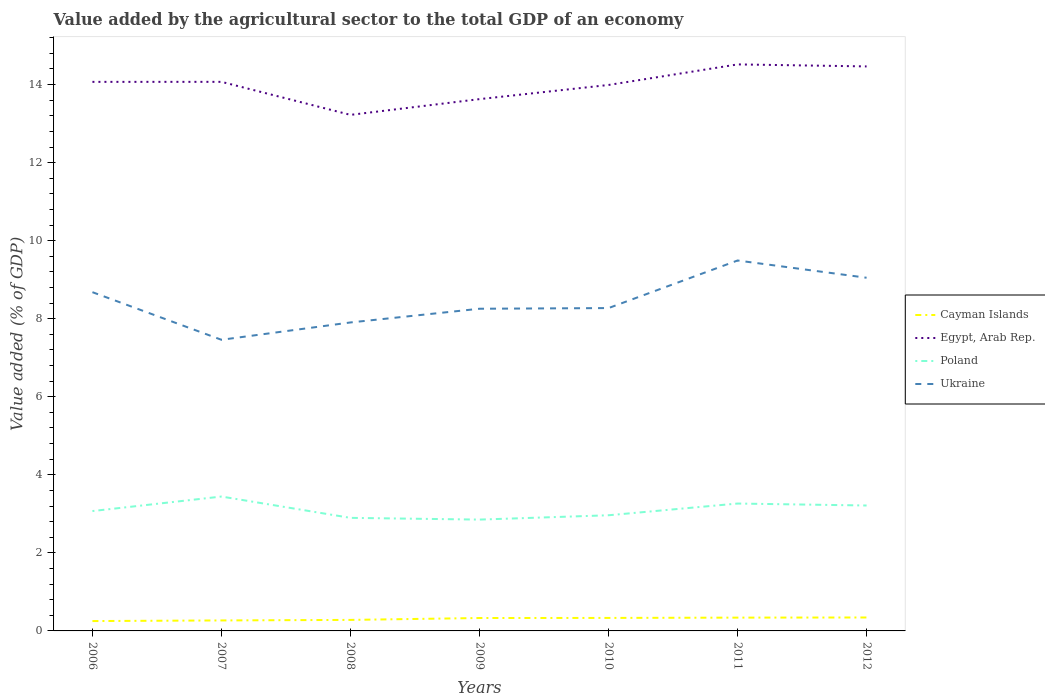How many different coloured lines are there?
Offer a terse response. 4. Across all years, what is the maximum value added by the agricultural sector to the total GDP in Poland?
Offer a very short reply. 2.85. In which year was the value added by the agricultural sector to the total GDP in Poland maximum?
Give a very brief answer. 2009. What is the total value added by the agricultural sector to the total GDP in Poland in the graph?
Make the answer very short. 0.17. What is the difference between the highest and the second highest value added by the agricultural sector to the total GDP in Cayman Islands?
Your response must be concise. 0.09. What is the difference between the highest and the lowest value added by the agricultural sector to the total GDP in Poland?
Your response must be concise. 3. Is the value added by the agricultural sector to the total GDP in Ukraine strictly greater than the value added by the agricultural sector to the total GDP in Egypt, Arab Rep. over the years?
Provide a succinct answer. Yes. How many lines are there?
Your response must be concise. 4. What is the difference between two consecutive major ticks on the Y-axis?
Your response must be concise. 2. Are the values on the major ticks of Y-axis written in scientific E-notation?
Give a very brief answer. No. Does the graph contain any zero values?
Offer a terse response. No. Where does the legend appear in the graph?
Ensure brevity in your answer.  Center right. How are the legend labels stacked?
Make the answer very short. Vertical. What is the title of the graph?
Your response must be concise. Value added by the agricultural sector to the total GDP of an economy. What is the label or title of the Y-axis?
Provide a short and direct response. Value added (% of GDP). What is the Value added (% of GDP) in Cayman Islands in 2006?
Give a very brief answer. 0.25. What is the Value added (% of GDP) of Egypt, Arab Rep. in 2006?
Provide a succinct answer. 14.07. What is the Value added (% of GDP) of Poland in 2006?
Provide a succinct answer. 3.07. What is the Value added (% of GDP) in Ukraine in 2006?
Give a very brief answer. 8.68. What is the Value added (% of GDP) in Cayman Islands in 2007?
Provide a succinct answer. 0.27. What is the Value added (% of GDP) in Egypt, Arab Rep. in 2007?
Provide a succinct answer. 14.07. What is the Value added (% of GDP) in Poland in 2007?
Make the answer very short. 3.44. What is the Value added (% of GDP) in Ukraine in 2007?
Make the answer very short. 7.46. What is the Value added (% of GDP) in Cayman Islands in 2008?
Give a very brief answer. 0.28. What is the Value added (% of GDP) in Egypt, Arab Rep. in 2008?
Keep it short and to the point. 13.22. What is the Value added (% of GDP) of Poland in 2008?
Offer a very short reply. 2.9. What is the Value added (% of GDP) of Ukraine in 2008?
Your response must be concise. 7.9. What is the Value added (% of GDP) in Cayman Islands in 2009?
Give a very brief answer. 0.33. What is the Value added (% of GDP) of Egypt, Arab Rep. in 2009?
Give a very brief answer. 13.63. What is the Value added (% of GDP) of Poland in 2009?
Offer a very short reply. 2.85. What is the Value added (% of GDP) of Ukraine in 2009?
Offer a terse response. 8.26. What is the Value added (% of GDP) of Cayman Islands in 2010?
Offer a very short reply. 0.33. What is the Value added (% of GDP) in Egypt, Arab Rep. in 2010?
Provide a succinct answer. 13.99. What is the Value added (% of GDP) in Poland in 2010?
Provide a succinct answer. 2.96. What is the Value added (% of GDP) in Ukraine in 2010?
Make the answer very short. 8.27. What is the Value added (% of GDP) of Cayman Islands in 2011?
Offer a terse response. 0.34. What is the Value added (% of GDP) in Egypt, Arab Rep. in 2011?
Offer a terse response. 14.52. What is the Value added (% of GDP) in Poland in 2011?
Offer a very short reply. 3.26. What is the Value added (% of GDP) of Ukraine in 2011?
Provide a short and direct response. 9.49. What is the Value added (% of GDP) in Cayman Islands in 2012?
Keep it short and to the point. 0.34. What is the Value added (% of GDP) in Egypt, Arab Rep. in 2012?
Offer a very short reply. 14.47. What is the Value added (% of GDP) of Poland in 2012?
Your answer should be compact. 3.21. What is the Value added (% of GDP) of Ukraine in 2012?
Offer a very short reply. 9.05. Across all years, what is the maximum Value added (% of GDP) in Cayman Islands?
Provide a short and direct response. 0.34. Across all years, what is the maximum Value added (% of GDP) in Egypt, Arab Rep.?
Your answer should be compact. 14.52. Across all years, what is the maximum Value added (% of GDP) of Poland?
Ensure brevity in your answer.  3.44. Across all years, what is the maximum Value added (% of GDP) in Ukraine?
Provide a succinct answer. 9.49. Across all years, what is the minimum Value added (% of GDP) of Cayman Islands?
Offer a very short reply. 0.25. Across all years, what is the minimum Value added (% of GDP) in Egypt, Arab Rep.?
Provide a succinct answer. 13.22. Across all years, what is the minimum Value added (% of GDP) in Poland?
Your answer should be very brief. 2.85. Across all years, what is the minimum Value added (% of GDP) of Ukraine?
Offer a terse response. 7.46. What is the total Value added (% of GDP) of Cayman Islands in the graph?
Your response must be concise. 2.15. What is the total Value added (% of GDP) in Egypt, Arab Rep. in the graph?
Offer a very short reply. 97.96. What is the total Value added (% of GDP) in Poland in the graph?
Your answer should be very brief. 21.71. What is the total Value added (% of GDP) in Ukraine in the graph?
Your answer should be very brief. 59.12. What is the difference between the Value added (% of GDP) of Cayman Islands in 2006 and that in 2007?
Provide a short and direct response. -0.02. What is the difference between the Value added (% of GDP) in Egypt, Arab Rep. in 2006 and that in 2007?
Provide a succinct answer. -0. What is the difference between the Value added (% of GDP) of Poland in 2006 and that in 2007?
Make the answer very short. -0.37. What is the difference between the Value added (% of GDP) of Ukraine in 2006 and that in 2007?
Offer a terse response. 1.22. What is the difference between the Value added (% of GDP) of Cayman Islands in 2006 and that in 2008?
Keep it short and to the point. -0.03. What is the difference between the Value added (% of GDP) of Egypt, Arab Rep. in 2006 and that in 2008?
Make the answer very short. 0.85. What is the difference between the Value added (% of GDP) of Poland in 2006 and that in 2008?
Ensure brevity in your answer.  0.17. What is the difference between the Value added (% of GDP) of Ukraine in 2006 and that in 2008?
Ensure brevity in your answer.  0.78. What is the difference between the Value added (% of GDP) in Cayman Islands in 2006 and that in 2009?
Offer a very short reply. -0.08. What is the difference between the Value added (% of GDP) in Egypt, Arab Rep. in 2006 and that in 2009?
Make the answer very short. 0.44. What is the difference between the Value added (% of GDP) of Poland in 2006 and that in 2009?
Keep it short and to the point. 0.22. What is the difference between the Value added (% of GDP) in Ukraine in 2006 and that in 2009?
Provide a short and direct response. 0.42. What is the difference between the Value added (% of GDP) of Cayman Islands in 2006 and that in 2010?
Offer a terse response. -0.08. What is the difference between the Value added (% of GDP) of Egypt, Arab Rep. in 2006 and that in 2010?
Your answer should be compact. 0.08. What is the difference between the Value added (% of GDP) of Poland in 2006 and that in 2010?
Offer a terse response. 0.11. What is the difference between the Value added (% of GDP) of Ukraine in 2006 and that in 2010?
Give a very brief answer. 0.41. What is the difference between the Value added (% of GDP) in Cayman Islands in 2006 and that in 2011?
Ensure brevity in your answer.  -0.09. What is the difference between the Value added (% of GDP) in Egypt, Arab Rep. in 2006 and that in 2011?
Your response must be concise. -0.45. What is the difference between the Value added (% of GDP) in Poland in 2006 and that in 2011?
Provide a short and direct response. -0.19. What is the difference between the Value added (% of GDP) in Ukraine in 2006 and that in 2011?
Keep it short and to the point. -0.81. What is the difference between the Value added (% of GDP) of Cayman Islands in 2006 and that in 2012?
Make the answer very short. -0.09. What is the difference between the Value added (% of GDP) of Egypt, Arab Rep. in 2006 and that in 2012?
Your response must be concise. -0.4. What is the difference between the Value added (% of GDP) of Poland in 2006 and that in 2012?
Your response must be concise. -0.14. What is the difference between the Value added (% of GDP) in Ukraine in 2006 and that in 2012?
Make the answer very short. -0.37. What is the difference between the Value added (% of GDP) in Cayman Islands in 2007 and that in 2008?
Your answer should be compact. -0.01. What is the difference between the Value added (% of GDP) of Egypt, Arab Rep. in 2007 and that in 2008?
Your answer should be very brief. 0.85. What is the difference between the Value added (% of GDP) in Poland in 2007 and that in 2008?
Provide a succinct answer. 0.55. What is the difference between the Value added (% of GDP) in Ukraine in 2007 and that in 2008?
Your response must be concise. -0.44. What is the difference between the Value added (% of GDP) of Cayman Islands in 2007 and that in 2009?
Ensure brevity in your answer.  -0.06. What is the difference between the Value added (% of GDP) of Egypt, Arab Rep. in 2007 and that in 2009?
Your response must be concise. 0.44. What is the difference between the Value added (% of GDP) of Poland in 2007 and that in 2009?
Offer a terse response. 0.59. What is the difference between the Value added (% of GDP) of Ukraine in 2007 and that in 2009?
Your response must be concise. -0.8. What is the difference between the Value added (% of GDP) of Cayman Islands in 2007 and that in 2010?
Ensure brevity in your answer.  -0.06. What is the difference between the Value added (% of GDP) in Egypt, Arab Rep. in 2007 and that in 2010?
Provide a succinct answer. 0.08. What is the difference between the Value added (% of GDP) of Poland in 2007 and that in 2010?
Your answer should be very brief. 0.48. What is the difference between the Value added (% of GDP) in Ukraine in 2007 and that in 2010?
Your response must be concise. -0.81. What is the difference between the Value added (% of GDP) in Cayman Islands in 2007 and that in 2011?
Offer a terse response. -0.07. What is the difference between the Value added (% of GDP) of Egypt, Arab Rep. in 2007 and that in 2011?
Provide a succinct answer. -0.45. What is the difference between the Value added (% of GDP) of Poland in 2007 and that in 2011?
Your answer should be very brief. 0.18. What is the difference between the Value added (% of GDP) in Ukraine in 2007 and that in 2011?
Ensure brevity in your answer.  -2.03. What is the difference between the Value added (% of GDP) of Cayman Islands in 2007 and that in 2012?
Your answer should be very brief. -0.08. What is the difference between the Value added (% of GDP) in Egypt, Arab Rep. in 2007 and that in 2012?
Give a very brief answer. -0.4. What is the difference between the Value added (% of GDP) in Poland in 2007 and that in 2012?
Your response must be concise. 0.23. What is the difference between the Value added (% of GDP) in Ukraine in 2007 and that in 2012?
Offer a terse response. -1.59. What is the difference between the Value added (% of GDP) in Cayman Islands in 2008 and that in 2009?
Offer a very short reply. -0.05. What is the difference between the Value added (% of GDP) in Egypt, Arab Rep. in 2008 and that in 2009?
Offer a terse response. -0.4. What is the difference between the Value added (% of GDP) of Poland in 2008 and that in 2009?
Give a very brief answer. 0.04. What is the difference between the Value added (% of GDP) of Ukraine in 2008 and that in 2009?
Provide a succinct answer. -0.35. What is the difference between the Value added (% of GDP) of Cayman Islands in 2008 and that in 2010?
Your answer should be compact. -0.05. What is the difference between the Value added (% of GDP) in Egypt, Arab Rep. in 2008 and that in 2010?
Ensure brevity in your answer.  -0.77. What is the difference between the Value added (% of GDP) of Poland in 2008 and that in 2010?
Your answer should be very brief. -0.07. What is the difference between the Value added (% of GDP) of Ukraine in 2008 and that in 2010?
Your answer should be compact. -0.37. What is the difference between the Value added (% of GDP) of Cayman Islands in 2008 and that in 2011?
Your response must be concise. -0.06. What is the difference between the Value added (% of GDP) of Egypt, Arab Rep. in 2008 and that in 2011?
Your answer should be compact. -1.29. What is the difference between the Value added (% of GDP) of Poland in 2008 and that in 2011?
Offer a very short reply. -0.37. What is the difference between the Value added (% of GDP) in Ukraine in 2008 and that in 2011?
Provide a succinct answer. -1.59. What is the difference between the Value added (% of GDP) of Cayman Islands in 2008 and that in 2012?
Your response must be concise. -0.06. What is the difference between the Value added (% of GDP) of Egypt, Arab Rep. in 2008 and that in 2012?
Provide a succinct answer. -1.24. What is the difference between the Value added (% of GDP) in Poland in 2008 and that in 2012?
Your answer should be very brief. -0.32. What is the difference between the Value added (% of GDP) of Ukraine in 2008 and that in 2012?
Your answer should be compact. -1.15. What is the difference between the Value added (% of GDP) in Cayman Islands in 2009 and that in 2010?
Make the answer very short. -0. What is the difference between the Value added (% of GDP) in Egypt, Arab Rep. in 2009 and that in 2010?
Your answer should be very brief. -0.36. What is the difference between the Value added (% of GDP) of Poland in 2009 and that in 2010?
Offer a very short reply. -0.11. What is the difference between the Value added (% of GDP) of Ukraine in 2009 and that in 2010?
Offer a terse response. -0.02. What is the difference between the Value added (% of GDP) in Cayman Islands in 2009 and that in 2011?
Offer a very short reply. -0.01. What is the difference between the Value added (% of GDP) in Egypt, Arab Rep. in 2009 and that in 2011?
Keep it short and to the point. -0.89. What is the difference between the Value added (% of GDP) of Poland in 2009 and that in 2011?
Offer a terse response. -0.41. What is the difference between the Value added (% of GDP) in Ukraine in 2009 and that in 2011?
Keep it short and to the point. -1.24. What is the difference between the Value added (% of GDP) of Cayman Islands in 2009 and that in 2012?
Your answer should be compact. -0.01. What is the difference between the Value added (% of GDP) of Egypt, Arab Rep. in 2009 and that in 2012?
Your answer should be very brief. -0.84. What is the difference between the Value added (% of GDP) in Poland in 2009 and that in 2012?
Offer a very short reply. -0.36. What is the difference between the Value added (% of GDP) of Ukraine in 2009 and that in 2012?
Your answer should be compact. -0.79. What is the difference between the Value added (% of GDP) in Cayman Islands in 2010 and that in 2011?
Your answer should be very brief. -0.01. What is the difference between the Value added (% of GDP) in Egypt, Arab Rep. in 2010 and that in 2011?
Give a very brief answer. -0.53. What is the difference between the Value added (% of GDP) of Poland in 2010 and that in 2011?
Your response must be concise. -0.3. What is the difference between the Value added (% of GDP) of Ukraine in 2010 and that in 2011?
Keep it short and to the point. -1.22. What is the difference between the Value added (% of GDP) of Cayman Islands in 2010 and that in 2012?
Make the answer very short. -0.01. What is the difference between the Value added (% of GDP) of Egypt, Arab Rep. in 2010 and that in 2012?
Offer a very short reply. -0.48. What is the difference between the Value added (% of GDP) of Ukraine in 2010 and that in 2012?
Provide a succinct answer. -0.78. What is the difference between the Value added (% of GDP) in Cayman Islands in 2011 and that in 2012?
Your response must be concise. -0. What is the difference between the Value added (% of GDP) of Egypt, Arab Rep. in 2011 and that in 2012?
Offer a very short reply. 0.05. What is the difference between the Value added (% of GDP) in Poland in 2011 and that in 2012?
Offer a very short reply. 0.05. What is the difference between the Value added (% of GDP) in Ukraine in 2011 and that in 2012?
Make the answer very short. 0.44. What is the difference between the Value added (% of GDP) in Cayman Islands in 2006 and the Value added (% of GDP) in Egypt, Arab Rep. in 2007?
Offer a terse response. -13.82. What is the difference between the Value added (% of GDP) in Cayman Islands in 2006 and the Value added (% of GDP) in Poland in 2007?
Your answer should be compact. -3.19. What is the difference between the Value added (% of GDP) in Cayman Islands in 2006 and the Value added (% of GDP) in Ukraine in 2007?
Give a very brief answer. -7.21. What is the difference between the Value added (% of GDP) of Egypt, Arab Rep. in 2006 and the Value added (% of GDP) of Poland in 2007?
Ensure brevity in your answer.  10.63. What is the difference between the Value added (% of GDP) in Egypt, Arab Rep. in 2006 and the Value added (% of GDP) in Ukraine in 2007?
Your answer should be very brief. 6.61. What is the difference between the Value added (% of GDP) of Poland in 2006 and the Value added (% of GDP) of Ukraine in 2007?
Keep it short and to the point. -4.39. What is the difference between the Value added (% of GDP) of Cayman Islands in 2006 and the Value added (% of GDP) of Egypt, Arab Rep. in 2008?
Keep it short and to the point. -12.97. What is the difference between the Value added (% of GDP) of Cayman Islands in 2006 and the Value added (% of GDP) of Poland in 2008?
Your answer should be very brief. -2.64. What is the difference between the Value added (% of GDP) of Cayman Islands in 2006 and the Value added (% of GDP) of Ukraine in 2008?
Provide a short and direct response. -7.65. What is the difference between the Value added (% of GDP) in Egypt, Arab Rep. in 2006 and the Value added (% of GDP) in Poland in 2008?
Provide a short and direct response. 11.17. What is the difference between the Value added (% of GDP) in Egypt, Arab Rep. in 2006 and the Value added (% of GDP) in Ukraine in 2008?
Provide a succinct answer. 6.17. What is the difference between the Value added (% of GDP) of Poland in 2006 and the Value added (% of GDP) of Ukraine in 2008?
Provide a succinct answer. -4.83. What is the difference between the Value added (% of GDP) in Cayman Islands in 2006 and the Value added (% of GDP) in Egypt, Arab Rep. in 2009?
Your answer should be very brief. -13.37. What is the difference between the Value added (% of GDP) in Cayman Islands in 2006 and the Value added (% of GDP) in Poland in 2009?
Make the answer very short. -2.6. What is the difference between the Value added (% of GDP) of Cayman Islands in 2006 and the Value added (% of GDP) of Ukraine in 2009?
Ensure brevity in your answer.  -8. What is the difference between the Value added (% of GDP) of Egypt, Arab Rep. in 2006 and the Value added (% of GDP) of Poland in 2009?
Provide a short and direct response. 11.22. What is the difference between the Value added (% of GDP) in Egypt, Arab Rep. in 2006 and the Value added (% of GDP) in Ukraine in 2009?
Provide a short and direct response. 5.81. What is the difference between the Value added (% of GDP) of Poland in 2006 and the Value added (% of GDP) of Ukraine in 2009?
Keep it short and to the point. -5.18. What is the difference between the Value added (% of GDP) of Cayman Islands in 2006 and the Value added (% of GDP) of Egypt, Arab Rep. in 2010?
Provide a succinct answer. -13.74. What is the difference between the Value added (% of GDP) of Cayman Islands in 2006 and the Value added (% of GDP) of Poland in 2010?
Give a very brief answer. -2.71. What is the difference between the Value added (% of GDP) in Cayman Islands in 2006 and the Value added (% of GDP) in Ukraine in 2010?
Provide a short and direct response. -8.02. What is the difference between the Value added (% of GDP) of Egypt, Arab Rep. in 2006 and the Value added (% of GDP) of Poland in 2010?
Provide a succinct answer. 11.11. What is the difference between the Value added (% of GDP) of Egypt, Arab Rep. in 2006 and the Value added (% of GDP) of Ukraine in 2010?
Provide a succinct answer. 5.8. What is the difference between the Value added (% of GDP) in Poland in 2006 and the Value added (% of GDP) in Ukraine in 2010?
Offer a terse response. -5.2. What is the difference between the Value added (% of GDP) of Cayman Islands in 2006 and the Value added (% of GDP) of Egypt, Arab Rep. in 2011?
Provide a short and direct response. -14.26. What is the difference between the Value added (% of GDP) of Cayman Islands in 2006 and the Value added (% of GDP) of Poland in 2011?
Offer a terse response. -3.01. What is the difference between the Value added (% of GDP) in Cayman Islands in 2006 and the Value added (% of GDP) in Ukraine in 2011?
Offer a very short reply. -9.24. What is the difference between the Value added (% of GDP) in Egypt, Arab Rep. in 2006 and the Value added (% of GDP) in Poland in 2011?
Make the answer very short. 10.81. What is the difference between the Value added (% of GDP) in Egypt, Arab Rep. in 2006 and the Value added (% of GDP) in Ukraine in 2011?
Offer a very short reply. 4.58. What is the difference between the Value added (% of GDP) of Poland in 2006 and the Value added (% of GDP) of Ukraine in 2011?
Provide a succinct answer. -6.42. What is the difference between the Value added (% of GDP) of Cayman Islands in 2006 and the Value added (% of GDP) of Egypt, Arab Rep. in 2012?
Ensure brevity in your answer.  -14.21. What is the difference between the Value added (% of GDP) of Cayman Islands in 2006 and the Value added (% of GDP) of Poland in 2012?
Ensure brevity in your answer.  -2.96. What is the difference between the Value added (% of GDP) of Cayman Islands in 2006 and the Value added (% of GDP) of Ukraine in 2012?
Offer a terse response. -8.8. What is the difference between the Value added (% of GDP) of Egypt, Arab Rep. in 2006 and the Value added (% of GDP) of Poland in 2012?
Offer a terse response. 10.86. What is the difference between the Value added (% of GDP) in Egypt, Arab Rep. in 2006 and the Value added (% of GDP) in Ukraine in 2012?
Give a very brief answer. 5.02. What is the difference between the Value added (% of GDP) of Poland in 2006 and the Value added (% of GDP) of Ukraine in 2012?
Your answer should be very brief. -5.98. What is the difference between the Value added (% of GDP) in Cayman Islands in 2007 and the Value added (% of GDP) in Egypt, Arab Rep. in 2008?
Your response must be concise. -12.96. What is the difference between the Value added (% of GDP) in Cayman Islands in 2007 and the Value added (% of GDP) in Poland in 2008?
Provide a succinct answer. -2.63. What is the difference between the Value added (% of GDP) of Cayman Islands in 2007 and the Value added (% of GDP) of Ukraine in 2008?
Give a very brief answer. -7.64. What is the difference between the Value added (% of GDP) of Egypt, Arab Rep. in 2007 and the Value added (% of GDP) of Poland in 2008?
Give a very brief answer. 11.17. What is the difference between the Value added (% of GDP) of Egypt, Arab Rep. in 2007 and the Value added (% of GDP) of Ukraine in 2008?
Your response must be concise. 6.17. What is the difference between the Value added (% of GDP) in Poland in 2007 and the Value added (% of GDP) in Ukraine in 2008?
Your answer should be very brief. -4.46. What is the difference between the Value added (% of GDP) of Cayman Islands in 2007 and the Value added (% of GDP) of Egypt, Arab Rep. in 2009?
Your answer should be very brief. -13.36. What is the difference between the Value added (% of GDP) of Cayman Islands in 2007 and the Value added (% of GDP) of Poland in 2009?
Your response must be concise. -2.58. What is the difference between the Value added (% of GDP) in Cayman Islands in 2007 and the Value added (% of GDP) in Ukraine in 2009?
Offer a terse response. -7.99. What is the difference between the Value added (% of GDP) in Egypt, Arab Rep. in 2007 and the Value added (% of GDP) in Poland in 2009?
Make the answer very short. 11.22. What is the difference between the Value added (% of GDP) of Egypt, Arab Rep. in 2007 and the Value added (% of GDP) of Ukraine in 2009?
Offer a terse response. 5.81. What is the difference between the Value added (% of GDP) in Poland in 2007 and the Value added (% of GDP) in Ukraine in 2009?
Give a very brief answer. -4.81. What is the difference between the Value added (% of GDP) of Cayman Islands in 2007 and the Value added (% of GDP) of Egypt, Arab Rep. in 2010?
Offer a terse response. -13.72. What is the difference between the Value added (% of GDP) in Cayman Islands in 2007 and the Value added (% of GDP) in Poland in 2010?
Provide a short and direct response. -2.7. What is the difference between the Value added (% of GDP) in Cayman Islands in 2007 and the Value added (% of GDP) in Ukraine in 2010?
Make the answer very short. -8. What is the difference between the Value added (% of GDP) in Egypt, Arab Rep. in 2007 and the Value added (% of GDP) in Poland in 2010?
Offer a very short reply. 11.11. What is the difference between the Value added (% of GDP) in Egypt, Arab Rep. in 2007 and the Value added (% of GDP) in Ukraine in 2010?
Provide a short and direct response. 5.8. What is the difference between the Value added (% of GDP) in Poland in 2007 and the Value added (% of GDP) in Ukraine in 2010?
Ensure brevity in your answer.  -4.83. What is the difference between the Value added (% of GDP) in Cayman Islands in 2007 and the Value added (% of GDP) in Egypt, Arab Rep. in 2011?
Offer a terse response. -14.25. What is the difference between the Value added (% of GDP) in Cayman Islands in 2007 and the Value added (% of GDP) in Poland in 2011?
Offer a terse response. -3. What is the difference between the Value added (% of GDP) of Cayman Islands in 2007 and the Value added (% of GDP) of Ukraine in 2011?
Your response must be concise. -9.22. What is the difference between the Value added (% of GDP) in Egypt, Arab Rep. in 2007 and the Value added (% of GDP) in Poland in 2011?
Offer a very short reply. 10.81. What is the difference between the Value added (% of GDP) of Egypt, Arab Rep. in 2007 and the Value added (% of GDP) of Ukraine in 2011?
Keep it short and to the point. 4.58. What is the difference between the Value added (% of GDP) of Poland in 2007 and the Value added (% of GDP) of Ukraine in 2011?
Your answer should be very brief. -6.05. What is the difference between the Value added (% of GDP) of Cayman Islands in 2007 and the Value added (% of GDP) of Egypt, Arab Rep. in 2012?
Keep it short and to the point. -14.2. What is the difference between the Value added (% of GDP) of Cayman Islands in 2007 and the Value added (% of GDP) of Poland in 2012?
Keep it short and to the point. -2.95. What is the difference between the Value added (% of GDP) of Cayman Islands in 2007 and the Value added (% of GDP) of Ukraine in 2012?
Make the answer very short. -8.78. What is the difference between the Value added (% of GDP) of Egypt, Arab Rep. in 2007 and the Value added (% of GDP) of Poland in 2012?
Make the answer very short. 10.86. What is the difference between the Value added (% of GDP) of Egypt, Arab Rep. in 2007 and the Value added (% of GDP) of Ukraine in 2012?
Make the answer very short. 5.02. What is the difference between the Value added (% of GDP) of Poland in 2007 and the Value added (% of GDP) of Ukraine in 2012?
Make the answer very short. -5.61. What is the difference between the Value added (% of GDP) in Cayman Islands in 2008 and the Value added (% of GDP) in Egypt, Arab Rep. in 2009?
Keep it short and to the point. -13.35. What is the difference between the Value added (% of GDP) of Cayman Islands in 2008 and the Value added (% of GDP) of Poland in 2009?
Give a very brief answer. -2.57. What is the difference between the Value added (% of GDP) in Cayman Islands in 2008 and the Value added (% of GDP) in Ukraine in 2009?
Make the answer very short. -7.97. What is the difference between the Value added (% of GDP) of Egypt, Arab Rep. in 2008 and the Value added (% of GDP) of Poland in 2009?
Offer a terse response. 10.37. What is the difference between the Value added (% of GDP) of Egypt, Arab Rep. in 2008 and the Value added (% of GDP) of Ukraine in 2009?
Your answer should be very brief. 4.97. What is the difference between the Value added (% of GDP) in Poland in 2008 and the Value added (% of GDP) in Ukraine in 2009?
Ensure brevity in your answer.  -5.36. What is the difference between the Value added (% of GDP) of Cayman Islands in 2008 and the Value added (% of GDP) of Egypt, Arab Rep. in 2010?
Offer a terse response. -13.71. What is the difference between the Value added (% of GDP) of Cayman Islands in 2008 and the Value added (% of GDP) of Poland in 2010?
Your response must be concise. -2.68. What is the difference between the Value added (% of GDP) in Cayman Islands in 2008 and the Value added (% of GDP) in Ukraine in 2010?
Make the answer very short. -7.99. What is the difference between the Value added (% of GDP) in Egypt, Arab Rep. in 2008 and the Value added (% of GDP) in Poland in 2010?
Ensure brevity in your answer.  10.26. What is the difference between the Value added (% of GDP) of Egypt, Arab Rep. in 2008 and the Value added (% of GDP) of Ukraine in 2010?
Offer a very short reply. 4.95. What is the difference between the Value added (% of GDP) in Poland in 2008 and the Value added (% of GDP) in Ukraine in 2010?
Offer a very short reply. -5.38. What is the difference between the Value added (% of GDP) of Cayman Islands in 2008 and the Value added (% of GDP) of Egypt, Arab Rep. in 2011?
Your response must be concise. -14.23. What is the difference between the Value added (% of GDP) in Cayman Islands in 2008 and the Value added (% of GDP) in Poland in 2011?
Your answer should be very brief. -2.98. What is the difference between the Value added (% of GDP) in Cayman Islands in 2008 and the Value added (% of GDP) in Ukraine in 2011?
Your response must be concise. -9.21. What is the difference between the Value added (% of GDP) of Egypt, Arab Rep. in 2008 and the Value added (% of GDP) of Poland in 2011?
Keep it short and to the point. 9.96. What is the difference between the Value added (% of GDP) of Egypt, Arab Rep. in 2008 and the Value added (% of GDP) of Ukraine in 2011?
Ensure brevity in your answer.  3.73. What is the difference between the Value added (% of GDP) in Poland in 2008 and the Value added (% of GDP) in Ukraine in 2011?
Your answer should be very brief. -6.59. What is the difference between the Value added (% of GDP) in Cayman Islands in 2008 and the Value added (% of GDP) in Egypt, Arab Rep. in 2012?
Offer a very short reply. -14.18. What is the difference between the Value added (% of GDP) in Cayman Islands in 2008 and the Value added (% of GDP) in Poland in 2012?
Your response must be concise. -2.93. What is the difference between the Value added (% of GDP) of Cayman Islands in 2008 and the Value added (% of GDP) of Ukraine in 2012?
Ensure brevity in your answer.  -8.77. What is the difference between the Value added (% of GDP) in Egypt, Arab Rep. in 2008 and the Value added (% of GDP) in Poland in 2012?
Give a very brief answer. 10.01. What is the difference between the Value added (% of GDP) in Egypt, Arab Rep. in 2008 and the Value added (% of GDP) in Ukraine in 2012?
Make the answer very short. 4.17. What is the difference between the Value added (% of GDP) in Poland in 2008 and the Value added (% of GDP) in Ukraine in 2012?
Give a very brief answer. -6.15. What is the difference between the Value added (% of GDP) of Cayman Islands in 2009 and the Value added (% of GDP) of Egypt, Arab Rep. in 2010?
Your response must be concise. -13.66. What is the difference between the Value added (% of GDP) of Cayman Islands in 2009 and the Value added (% of GDP) of Poland in 2010?
Make the answer very short. -2.63. What is the difference between the Value added (% of GDP) of Cayman Islands in 2009 and the Value added (% of GDP) of Ukraine in 2010?
Provide a succinct answer. -7.94. What is the difference between the Value added (% of GDP) of Egypt, Arab Rep. in 2009 and the Value added (% of GDP) of Poland in 2010?
Keep it short and to the point. 10.66. What is the difference between the Value added (% of GDP) of Egypt, Arab Rep. in 2009 and the Value added (% of GDP) of Ukraine in 2010?
Offer a terse response. 5.35. What is the difference between the Value added (% of GDP) in Poland in 2009 and the Value added (% of GDP) in Ukraine in 2010?
Ensure brevity in your answer.  -5.42. What is the difference between the Value added (% of GDP) in Cayman Islands in 2009 and the Value added (% of GDP) in Egypt, Arab Rep. in 2011?
Your response must be concise. -14.19. What is the difference between the Value added (% of GDP) of Cayman Islands in 2009 and the Value added (% of GDP) of Poland in 2011?
Offer a very short reply. -2.93. What is the difference between the Value added (% of GDP) of Cayman Islands in 2009 and the Value added (% of GDP) of Ukraine in 2011?
Keep it short and to the point. -9.16. What is the difference between the Value added (% of GDP) of Egypt, Arab Rep. in 2009 and the Value added (% of GDP) of Poland in 2011?
Your response must be concise. 10.36. What is the difference between the Value added (% of GDP) in Egypt, Arab Rep. in 2009 and the Value added (% of GDP) in Ukraine in 2011?
Your response must be concise. 4.14. What is the difference between the Value added (% of GDP) of Poland in 2009 and the Value added (% of GDP) of Ukraine in 2011?
Your answer should be very brief. -6.64. What is the difference between the Value added (% of GDP) of Cayman Islands in 2009 and the Value added (% of GDP) of Egypt, Arab Rep. in 2012?
Keep it short and to the point. -14.13. What is the difference between the Value added (% of GDP) in Cayman Islands in 2009 and the Value added (% of GDP) in Poland in 2012?
Keep it short and to the point. -2.88. What is the difference between the Value added (% of GDP) in Cayman Islands in 2009 and the Value added (% of GDP) in Ukraine in 2012?
Your answer should be compact. -8.72. What is the difference between the Value added (% of GDP) in Egypt, Arab Rep. in 2009 and the Value added (% of GDP) in Poland in 2012?
Keep it short and to the point. 10.41. What is the difference between the Value added (% of GDP) of Egypt, Arab Rep. in 2009 and the Value added (% of GDP) of Ukraine in 2012?
Your answer should be compact. 4.58. What is the difference between the Value added (% of GDP) of Poland in 2009 and the Value added (% of GDP) of Ukraine in 2012?
Keep it short and to the point. -6.2. What is the difference between the Value added (% of GDP) of Cayman Islands in 2010 and the Value added (% of GDP) of Egypt, Arab Rep. in 2011?
Ensure brevity in your answer.  -14.18. What is the difference between the Value added (% of GDP) in Cayman Islands in 2010 and the Value added (% of GDP) in Poland in 2011?
Keep it short and to the point. -2.93. What is the difference between the Value added (% of GDP) of Cayman Islands in 2010 and the Value added (% of GDP) of Ukraine in 2011?
Keep it short and to the point. -9.16. What is the difference between the Value added (% of GDP) of Egypt, Arab Rep. in 2010 and the Value added (% of GDP) of Poland in 2011?
Provide a succinct answer. 10.73. What is the difference between the Value added (% of GDP) in Egypt, Arab Rep. in 2010 and the Value added (% of GDP) in Ukraine in 2011?
Your answer should be compact. 4.5. What is the difference between the Value added (% of GDP) of Poland in 2010 and the Value added (% of GDP) of Ukraine in 2011?
Your answer should be compact. -6.53. What is the difference between the Value added (% of GDP) of Cayman Islands in 2010 and the Value added (% of GDP) of Egypt, Arab Rep. in 2012?
Your answer should be compact. -14.13. What is the difference between the Value added (% of GDP) in Cayman Islands in 2010 and the Value added (% of GDP) in Poland in 2012?
Your answer should be compact. -2.88. What is the difference between the Value added (% of GDP) in Cayman Islands in 2010 and the Value added (% of GDP) in Ukraine in 2012?
Ensure brevity in your answer.  -8.72. What is the difference between the Value added (% of GDP) in Egypt, Arab Rep. in 2010 and the Value added (% of GDP) in Poland in 2012?
Ensure brevity in your answer.  10.78. What is the difference between the Value added (% of GDP) in Egypt, Arab Rep. in 2010 and the Value added (% of GDP) in Ukraine in 2012?
Provide a short and direct response. 4.94. What is the difference between the Value added (% of GDP) of Poland in 2010 and the Value added (% of GDP) of Ukraine in 2012?
Give a very brief answer. -6.09. What is the difference between the Value added (% of GDP) of Cayman Islands in 2011 and the Value added (% of GDP) of Egypt, Arab Rep. in 2012?
Your response must be concise. -14.12. What is the difference between the Value added (% of GDP) of Cayman Islands in 2011 and the Value added (% of GDP) of Poland in 2012?
Your response must be concise. -2.87. What is the difference between the Value added (% of GDP) in Cayman Islands in 2011 and the Value added (% of GDP) in Ukraine in 2012?
Ensure brevity in your answer.  -8.71. What is the difference between the Value added (% of GDP) of Egypt, Arab Rep. in 2011 and the Value added (% of GDP) of Poland in 2012?
Provide a short and direct response. 11.3. What is the difference between the Value added (% of GDP) of Egypt, Arab Rep. in 2011 and the Value added (% of GDP) of Ukraine in 2012?
Your answer should be compact. 5.47. What is the difference between the Value added (% of GDP) of Poland in 2011 and the Value added (% of GDP) of Ukraine in 2012?
Provide a succinct answer. -5.79. What is the average Value added (% of GDP) in Cayman Islands per year?
Your answer should be very brief. 0.31. What is the average Value added (% of GDP) of Egypt, Arab Rep. per year?
Your answer should be compact. 13.99. What is the average Value added (% of GDP) in Poland per year?
Offer a terse response. 3.1. What is the average Value added (% of GDP) in Ukraine per year?
Give a very brief answer. 8.45. In the year 2006, what is the difference between the Value added (% of GDP) of Cayman Islands and Value added (% of GDP) of Egypt, Arab Rep.?
Offer a terse response. -13.82. In the year 2006, what is the difference between the Value added (% of GDP) of Cayman Islands and Value added (% of GDP) of Poland?
Your answer should be compact. -2.82. In the year 2006, what is the difference between the Value added (% of GDP) in Cayman Islands and Value added (% of GDP) in Ukraine?
Offer a terse response. -8.43. In the year 2006, what is the difference between the Value added (% of GDP) in Egypt, Arab Rep. and Value added (% of GDP) in Poland?
Make the answer very short. 11. In the year 2006, what is the difference between the Value added (% of GDP) of Egypt, Arab Rep. and Value added (% of GDP) of Ukraine?
Your answer should be very brief. 5.39. In the year 2006, what is the difference between the Value added (% of GDP) of Poland and Value added (% of GDP) of Ukraine?
Your answer should be very brief. -5.61. In the year 2007, what is the difference between the Value added (% of GDP) in Cayman Islands and Value added (% of GDP) in Egypt, Arab Rep.?
Give a very brief answer. -13.8. In the year 2007, what is the difference between the Value added (% of GDP) in Cayman Islands and Value added (% of GDP) in Poland?
Keep it short and to the point. -3.17. In the year 2007, what is the difference between the Value added (% of GDP) in Cayman Islands and Value added (% of GDP) in Ukraine?
Your answer should be compact. -7.19. In the year 2007, what is the difference between the Value added (% of GDP) of Egypt, Arab Rep. and Value added (% of GDP) of Poland?
Make the answer very short. 10.63. In the year 2007, what is the difference between the Value added (% of GDP) of Egypt, Arab Rep. and Value added (% of GDP) of Ukraine?
Provide a succinct answer. 6.61. In the year 2007, what is the difference between the Value added (% of GDP) of Poland and Value added (% of GDP) of Ukraine?
Ensure brevity in your answer.  -4.02. In the year 2008, what is the difference between the Value added (% of GDP) of Cayman Islands and Value added (% of GDP) of Egypt, Arab Rep.?
Provide a short and direct response. -12.94. In the year 2008, what is the difference between the Value added (% of GDP) in Cayman Islands and Value added (% of GDP) in Poland?
Your response must be concise. -2.61. In the year 2008, what is the difference between the Value added (% of GDP) of Cayman Islands and Value added (% of GDP) of Ukraine?
Keep it short and to the point. -7.62. In the year 2008, what is the difference between the Value added (% of GDP) in Egypt, Arab Rep. and Value added (% of GDP) in Poland?
Offer a terse response. 10.33. In the year 2008, what is the difference between the Value added (% of GDP) of Egypt, Arab Rep. and Value added (% of GDP) of Ukraine?
Your answer should be compact. 5.32. In the year 2008, what is the difference between the Value added (% of GDP) in Poland and Value added (% of GDP) in Ukraine?
Offer a very short reply. -5.01. In the year 2009, what is the difference between the Value added (% of GDP) of Cayman Islands and Value added (% of GDP) of Egypt, Arab Rep.?
Offer a terse response. -13.3. In the year 2009, what is the difference between the Value added (% of GDP) in Cayman Islands and Value added (% of GDP) in Poland?
Your response must be concise. -2.52. In the year 2009, what is the difference between the Value added (% of GDP) in Cayman Islands and Value added (% of GDP) in Ukraine?
Keep it short and to the point. -7.93. In the year 2009, what is the difference between the Value added (% of GDP) in Egypt, Arab Rep. and Value added (% of GDP) in Poland?
Offer a terse response. 10.77. In the year 2009, what is the difference between the Value added (% of GDP) of Egypt, Arab Rep. and Value added (% of GDP) of Ukraine?
Give a very brief answer. 5.37. In the year 2009, what is the difference between the Value added (% of GDP) of Poland and Value added (% of GDP) of Ukraine?
Your response must be concise. -5.4. In the year 2010, what is the difference between the Value added (% of GDP) in Cayman Islands and Value added (% of GDP) in Egypt, Arab Rep.?
Offer a terse response. -13.66. In the year 2010, what is the difference between the Value added (% of GDP) in Cayman Islands and Value added (% of GDP) in Poland?
Your answer should be compact. -2.63. In the year 2010, what is the difference between the Value added (% of GDP) of Cayman Islands and Value added (% of GDP) of Ukraine?
Provide a succinct answer. -7.94. In the year 2010, what is the difference between the Value added (% of GDP) in Egypt, Arab Rep. and Value added (% of GDP) in Poland?
Offer a very short reply. 11.03. In the year 2010, what is the difference between the Value added (% of GDP) of Egypt, Arab Rep. and Value added (% of GDP) of Ukraine?
Your answer should be very brief. 5.72. In the year 2010, what is the difference between the Value added (% of GDP) of Poland and Value added (% of GDP) of Ukraine?
Provide a succinct answer. -5.31. In the year 2011, what is the difference between the Value added (% of GDP) in Cayman Islands and Value added (% of GDP) in Egypt, Arab Rep.?
Your response must be concise. -14.18. In the year 2011, what is the difference between the Value added (% of GDP) in Cayman Islands and Value added (% of GDP) in Poland?
Your answer should be very brief. -2.92. In the year 2011, what is the difference between the Value added (% of GDP) of Cayman Islands and Value added (% of GDP) of Ukraine?
Make the answer very short. -9.15. In the year 2011, what is the difference between the Value added (% of GDP) of Egypt, Arab Rep. and Value added (% of GDP) of Poland?
Keep it short and to the point. 11.25. In the year 2011, what is the difference between the Value added (% of GDP) of Egypt, Arab Rep. and Value added (% of GDP) of Ukraine?
Make the answer very short. 5.02. In the year 2011, what is the difference between the Value added (% of GDP) in Poland and Value added (% of GDP) in Ukraine?
Your answer should be very brief. -6.23. In the year 2012, what is the difference between the Value added (% of GDP) of Cayman Islands and Value added (% of GDP) of Egypt, Arab Rep.?
Offer a terse response. -14.12. In the year 2012, what is the difference between the Value added (% of GDP) of Cayman Islands and Value added (% of GDP) of Poland?
Offer a terse response. -2.87. In the year 2012, what is the difference between the Value added (% of GDP) in Cayman Islands and Value added (% of GDP) in Ukraine?
Your response must be concise. -8.71. In the year 2012, what is the difference between the Value added (% of GDP) in Egypt, Arab Rep. and Value added (% of GDP) in Poland?
Offer a terse response. 11.25. In the year 2012, what is the difference between the Value added (% of GDP) of Egypt, Arab Rep. and Value added (% of GDP) of Ukraine?
Keep it short and to the point. 5.42. In the year 2012, what is the difference between the Value added (% of GDP) in Poland and Value added (% of GDP) in Ukraine?
Your answer should be compact. -5.84. What is the ratio of the Value added (% of GDP) in Cayman Islands in 2006 to that in 2007?
Make the answer very short. 0.94. What is the ratio of the Value added (% of GDP) in Egypt, Arab Rep. in 2006 to that in 2007?
Provide a short and direct response. 1. What is the ratio of the Value added (% of GDP) of Poland in 2006 to that in 2007?
Make the answer very short. 0.89. What is the ratio of the Value added (% of GDP) of Ukraine in 2006 to that in 2007?
Make the answer very short. 1.16. What is the ratio of the Value added (% of GDP) in Cayman Islands in 2006 to that in 2008?
Keep it short and to the point. 0.9. What is the ratio of the Value added (% of GDP) in Egypt, Arab Rep. in 2006 to that in 2008?
Give a very brief answer. 1.06. What is the ratio of the Value added (% of GDP) of Poland in 2006 to that in 2008?
Give a very brief answer. 1.06. What is the ratio of the Value added (% of GDP) of Ukraine in 2006 to that in 2008?
Make the answer very short. 1.1. What is the ratio of the Value added (% of GDP) of Cayman Islands in 2006 to that in 2009?
Offer a terse response. 0.76. What is the ratio of the Value added (% of GDP) in Egypt, Arab Rep. in 2006 to that in 2009?
Provide a short and direct response. 1.03. What is the ratio of the Value added (% of GDP) in Poland in 2006 to that in 2009?
Make the answer very short. 1.08. What is the ratio of the Value added (% of GDP) of Ukraine in 2006 to that in 2009?
Make the answer very short. 1.05. What is the ratio of the Value added (% of GDP) in Cayman Islands in 2006 to that in 2010?
Keep it short and to the point. 0.76. What is the ratio of the Value added (% of GDP) in Egypt, Arab Rep. in 2006 to that in 2010?
Provide a succinct answer. 1.01. What is the ratio of the Value added (% of GDP) of Poland in 2006 to that in 2010?
Keep it short and to the point. 1.04. What is the ratio of the Value added (% of GDP) in Ukraine in 2006 to that in 2010?
Your answer should be compact. 1.05. What is the ratio of the Value added (% of GDP) in Cayman Islands in 2006 to that in 2011?
Keep it short and to the point. 0.74. What is the ratio of the Value added (% of GDP) in Egypt, Arab Rep. in 2006 to that in 2011?
Give a very brief answer. 0.97. What is the ratio of the Value added (% of GDP) in Poland in 2006 to that in 2011?
Provide a succinct answer. 0.94. What is the ratio of the Value added (% of GDP) in Ukraine in 2006 to that in 2011?
Your answer should be compact. 0.91. What is the ratio of the Value added (% of GDP) in Cayman Islands in 2006 to that in 2012?
Your response must be concise. 0.73. What is the ratio of the Value added (% of GDP) in Egypt, Arab Rep. in 2006 to that in 2012?
Your response must be concise. 0.97. What is the ratio of the Value added (% of GDP) in Poland in 2006 to that in 2012?
Make the answer very short. 0.96. What is the ratio of the Value added (% of GDP) of Ukraine in 2006 to that in 2012?
Your answer should be very brief. 0.96. What is the ratio of the Value added (% of GDP) in Cayman Islands in 2007 to that in 2008?
Give a very brief answer. 0.95. What is the ratio of the Value added (% of GDP) in Egypt, Arab Rep. in 2007 to that in 2008?
Provide a short and direct response. 1.06. What is the ratio of the Value added (% of GDP) in Poland in 2007 to that in 2008?
Offer a very short reply. 1.19. What is the ratio of the Value added (% of GDP) of Ukraine in 2007 to that in 2008?
Your response must be concise. 0.94. What is the ratio of the Value added (% of GDP) of Cayman Islands in 2007 to that in 2009?
Your response must be concise. 0.81. What is the ratio of the Value added (% of GDP) of Egypt, Arab Rep. in 2007 to that in 2009?
Offer a terse response. 1.03. What is the ratio of the Value added (% of GDP) in Poland in 2007 to that in 2009?
Give a very brief answer. 1.21. What is the ratio of the Value added (% of GDP) of Ukraine in 2007 to that in 2009?
Your answer should be very brief. 0.9. What is the ratio of the Value added (% of GDP) in Cayman Islands in 2007 to that in 2010?
Your answer should be compact. 0.81. What is the ratio of the Value added (% of GDP) in Poland in 2007 to that in 2010?
Make the answer very short. 1.16. What is the ratio of the Value added (% of GDP) of Ukraine in 2007 to that in 2010?
Give a very brief answer. 0.9. What is the ratio of the Value added (% of GDP) of Cayman Islands in 2007 to that in 2011?
Your answer should be compact. 0.79. What is the ratio of the Value added (% of GDP) in Egypt, Arab Rep. in 2007 to that in 2011?
Make the answer very short. 0.97. What is the ratio of the Value added (% of GDP) of Poland in 2007 to that in 2011?
Your response must be concise. 1.05. What is the ratio of the Value added (% of GDP) in Ukraine in 2007 to that in 2011?
Provide a succinct answer. 0.79. What is the ratio of the Value added (% of GDP) in Cayman Islands in 2007 to that in 2012?
Offer a very short reply. 0.78. What is the ratio of the Value added (% of GDP) of Egypt, Arab Rep. in 2007 to that in 2012?
Your answer should be very brief. 0.97. What is the ratio of the Value added (% of GDP) of Poland in 2007 to that in 2012?
Your response must be concise. 1.07. What is the ratio of the Value added (% of GDP) of Ukraine in 2007 to that in 2012?
Provide a short and direct response. 0.82. What is the ratio of the Value added (% of GDP) in Cayman Islands in 2008 to that in 2009?
Provide a short and direct response. 0.85. What is the ratio of the Value added (% of GDP) in Egypt, Arab Rep. in 2008 to that in 2009?
Your answer should be compact. 0.97. What is the ratio of the Value added (% of GDP) in Poland in 2008 to that in 2009?
Provide a short and direct response. 1.02. What is the ratio of the Value added (% of GDP) of Ukraine in 2008 to that in 2009?
Give a very brief answer. 0.96. What is the ratio of the Value added (% of GDP) in Cayman Islands in 2008 to that in 2010?
Offer a very short reply. 0.85. What is the ratio of the Value added (% of GDP) in Egypt, Arab Rep. in 2008 to that in 2010?
Give a very brief answer. 0.95. What is the ratio of the Value added (% of GDP) of Poland in 2008 to that in 2010?
Your answer should be compact. 0.98. What is the ratio of the Value added (% of GDP) of Ukraine in 2008 to that in 2010?
Provide a succinct answer. 0.96. What is the ratio of the Value added (% of GDP) in Cayman Islands in 2008 to that in 2011?
Give a very brief answer. 0.83. What is the ratio of the Value added (% of GDP) of Egypt, Arab Rep. in 2008 to that in 2011?
Give a very brief answer. 0.91. What is the ratio of the Value added (% of GDP) in Poland in 2008 to that in 2011?
Provide a short and direct response. 0.89. What is the ratio of the Value added (% of GDP) in Ukraine in 2008 to that in 2011?
Your answer should be very brief. 0.83. What is the ratio of the Value added (% of GDP) of Cayman Islands in 2008 to that in 2012?
Offer a very short reply. 0.82. What is the ratio of the Value added (% of GDP) in Egypt, Arab Rep. in 2008 to that in 2012?
Your answer should be compact. 0.91. What is the ratio of the Value added (% of GDP) of Poland in 2008 to that in 2012?
Give a very brief answer. 0.9. What is the ratio of the Value added (% of GDP) of Ukraine in 2008 to that in 2012?
Provide a succinct answer. 0.87. What is the ratio of the Value added (% of GDP) in Cayman Islands in 2009 to that in 2010?
Your answer should be compact. 0.99. What is the ratio of the Value added (% of GDP) of Egypt, Arab Rep. in 2009 to that in 2010?
Make the answer very short. 0.97. What is the ratio of the Value added (% of GDP) in Poland in 2009 to that in 2010?
Your response must be concise. 0.96. What is the ratio of the Value added (% of GDP) in Cayman Islands in 2009 to that in 2011?
Provide a succinct answer. 0.97. What is the ratio of the Value added (% of GDP) in Egypt, Arab Rep. in 2009 to that in 2011?
Your response must be concise. 0.94. What is the ratio of the Value added (% of GDP) of Poland in 2009 to that in 2011?
Offer a terse response. 0.87. What is the ratio of the Value added (% of GDP) in Ukraine in 2009 to that in 2011?
Make the answer very short. 0.87. What is the ratio of the Value added (% of GDP) of Cayman Islands in 2009 to that in 2012?
Ensure brevity in your answer.  0.96. What is the ratio of the Value added (% of GDP) in Egypt, Arab Rep. in 2009 to that in 2012?
Make the answer very short. 0.94. What is the ratio of the Value added (% of GDP) of Poland in 2009 to that in 2012?
Provide a short and direct response. 0.89. What is the ratio of the Value added (% of GDP) of Ukraine in 2009 to that in 2012?
Make the answer very short. 0.91. What is the ratio of the Value added (% of GDP) of Cayman Islands in 2010 to that in 2011?
Provide a short and direct response. 0.98. What is the ratio of the Value added (% of GDP) in Egypt, Arab Rep. in 2010 to that in 2011?
Keep it short and to the point. 0.96. What is the ratio of the Value added (% of GDP) in Poland in 2010 to that in 2011?
Keep it short and to the point. 0.91. What is the ratio of the Value added (% of GDP) of Ukraine in 2010 to that in 2011?
Offer a terse response. 0.87. What is the ratio of the Value added (% of GDP) of Cayman Islands in 2010 to that in 2012?
Offer a very short reply. 0.97. What is the ratio of the Value added (% of GDP) in Egypt, Arab Rep. in 2010 to that in 2012?
Your response must be concise. 0.97. What is the ratio of the Value added (% of GDP) of Poland in 2010 to that in 2012?
Your answer should be very brief. 0.92. What is the ratio of the Value added (% of GDP) of Ukraine in 2010 to that in 2012?
Provide a succinct answer. 0.91. What is the ratio of the Value added (% of GDP) in Egypt, Arab Rep. in 2011 to that in 2012?
Give a very brief answer. 1. What is the ratio of the Value added (% of GDP) in Poland in 2011 to that in 2012?
Offer a very short reply. 1.02. What is the ratio of the Value added (% of GDP) in Ukraine in 2011 to that in 2012?
Your answer should be very brief. 1.05. What is the difference between the highest and the second highest Value added (% of GDP) of Cayman Islands?
Offer a very short reply. 0. What is the difference between the highest and the second highest Value added (% of GDP) of Egypt, Arab Rep.?
Ensure brevity in your answer.  0.05. What is the difference between the highest and the second highest Value added (% of GDP) in Poland?
Your response must be concise. 0.18. What is the difference between the highest and the second highest Value added (% of GDP) of Ukraine?
Provide a succinct answer. 0.44. What is the difference between the highest and the lowest Value added (% of GDP) of Cayman Islands?
Your answer should be very brief. 0.09. What is the difference between the highest and the lowest Value added (% of GDP) of Egypt, Arab Rep.?
Your answer should be compact. 1.29. What is the difference between the highest and the lowest Value added (% of GDP) in Poland?
Make the answer very short. 0.59. What is the difference between the highest and the lowest Value added (% of GDP) of Ukraine?
Ensure brevity in your answer.  2.03. 